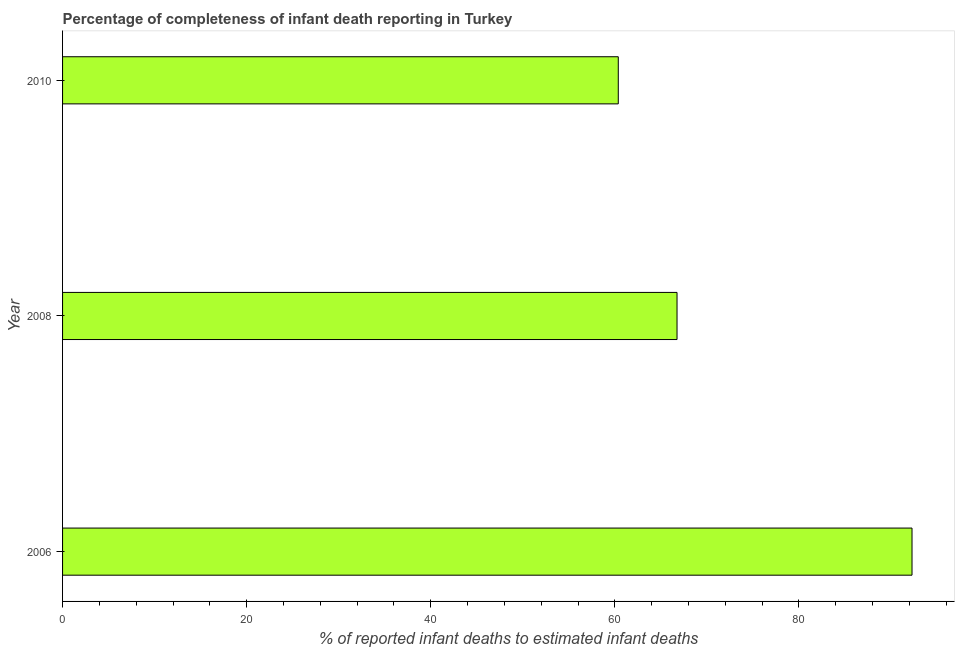What is the title of the graph?
Keep it short and to the point. Percentage of completeness of infant death reporting in Turkey. What is the label or title of the X-axis?
Keep it short and to the point. % of reported infant deaths to estimated infant deaths. What is the label or title of the Y-axis?
Offer a very short reply. Year. What is the completeness of infant death reporting in 2006?
Your response must be concise. 92.29. Across all years, what is the maximum completeness of infant death reporting?
Offer a very short reply. 92.29. Across all years, what is the minimum completeness of infant death reporting?
Ensure brevity in your answer.  60.37. In which year was the completeness of infant death reporting maximum?
Provide a short and direct response. 2006. In which year was the completeness of infant death reporting minimum?
Your answer should be compact. 2010. What is the sum of the completeness of infant death reporting?
Your response must be concise. 219.42. What is the difference between the completeness of infant death reporting in 2008 and 2010?
Provide a short and direct response. 6.38. What is the average completeness of infant death reporting per year?
Provide a short and direct response. 73.14. What is the median completeness of infant death reporting?
Provide a succinct answer. 66.76. Do a majority of the years between 2006 and 2010 (inclusive) have completeness of infant death reporting greater than 64 %?
Your response must be concise. Yes. What is the ratio of the completeness of infant death reporting in 2006 to that in 2008?
Offer a very short reply. 1.38. Is the completeness of infant death reporting in 2006 less than that in 2008?
Your answer should be very brief. No. What is the difference between the highest and the second highest completeness of infant death reporting?
Provide a short and direct response. 25.53. Is the sum of the completeness of infant death reporting in 2008 and 2010 greater than the maximum completeness of infant death reporting across all years?
Your response must be concise. Yes. What is the difference between the highest and the lowest completeness of infant death reporting?
Keep it short and to the point. 31.91. Are all the bars in the graph horizontal?
Keep it short and to the point. Yes. What is the difference between two consecutive major ticks on the X-axis?
Ensure brevity in your answer.  20. Are the values on the major ticks of X-axis written in scientific E-notation?
Ensure brevity in your answer.  No. What is the % of reported infant deaths to estimated infant deaths in 2006?
Provide a succinct answer. 92.29. What is the % of reported infant deaths to estimated infant deaths in 2008?
Offer a terse response. 66.76. What is the % of reported infant deaths to estimated infant deaths of 2010?
Your response must be concise. 60.37. What is the difference between the % of reported infant deaths to estimated infant deaths in 2006 and 2008?
Keep it short and to the point. 25.53. What is the difference between the % of reported infant deaths to estimated infant deaths in 2006 and 2010?
Your answer should be compact. 31.91. What is the difference between the % of reported infant deaths to estimated infant deaths in 2008 and 2010?
Give a very brief answer. 6.38. What is the ratio of the % of reported infant deaths to estimated infant deaths in 2006 to that in 2008?
Offer a terse response. 1.38. What is the ratio of the % of reported infant deaths to estimated infant deaths in 2006 to that in 2010?
Provide a short and direct response. 1.53. What is the ratio of the % of reported infant deaths to estimated infant deaths in 2008 to that in 2010?
Offer a terse response. 1.11. 